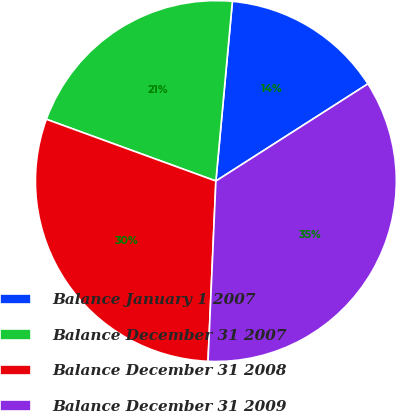Convert chart to OTSL. <chart><loc_0><loc_0><loc_500><loc_500><pie_chart><fcel>Balance January 1 2007<fcel>Balance December 31 2007<fcel>Balance December 31 2008<fcel>Balance December 31 2009<nl><fcel>14.49%<fcel>20.9%<fcel>29.87%<fcel>34.75%<nl></chart> 